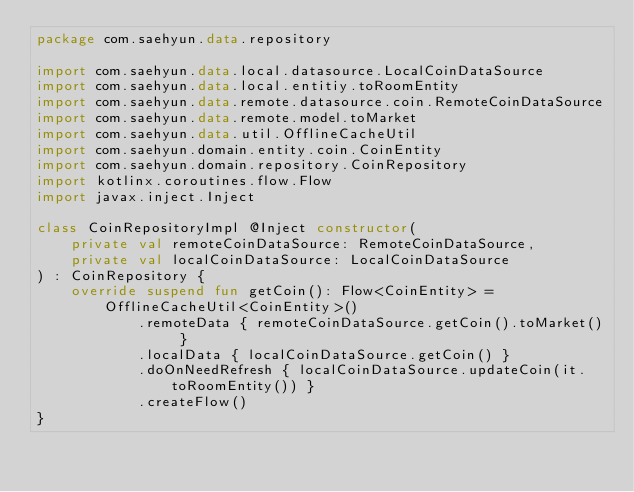<code> <loc_0><loc_0><loc_500><loc_500><_Kotlin_>package com.saehyun.data.repository

import com.saehyun.data.local.datasource.LocalCoinDataSource
import com.saehyun.data.local.entitiy.toRoomEntity
import com.saehyun.data.remote.datasource.coin.RemoteCoinDataSource
import com.saehyun.data.remote.model.toMarket
import com.saehyun.data.util.OfflineCacheUtil
import com.saehyun.domain.entity.coin.CoinEntity
import com.saehyun.domain.repository.CoinRepository
import kotlinx.coroutines.flow.Flow
import javax.inject.Inject

class CoinRepositoryImpl @Inject constructor(
    private val remoteCoinDataSource: RemoteCoinDataSource,
    private val localCoinDataSource: LocalCoinDataSource
) : CoinRepository {
    override suspend fun getCoin(): Flow<CoinEntity> =
        OfflineCacheUtil<CoinEntity>()
            .remoteData { remoteCoinDataSource.getCoin().toMarket() }
            .localData { localCoinDataSource.getCoin() }
            .doOnNeedRefresh { localCoinDataSource.updateCoin(it.toRoomEntity()) }
            .createFlow()
}</code> 